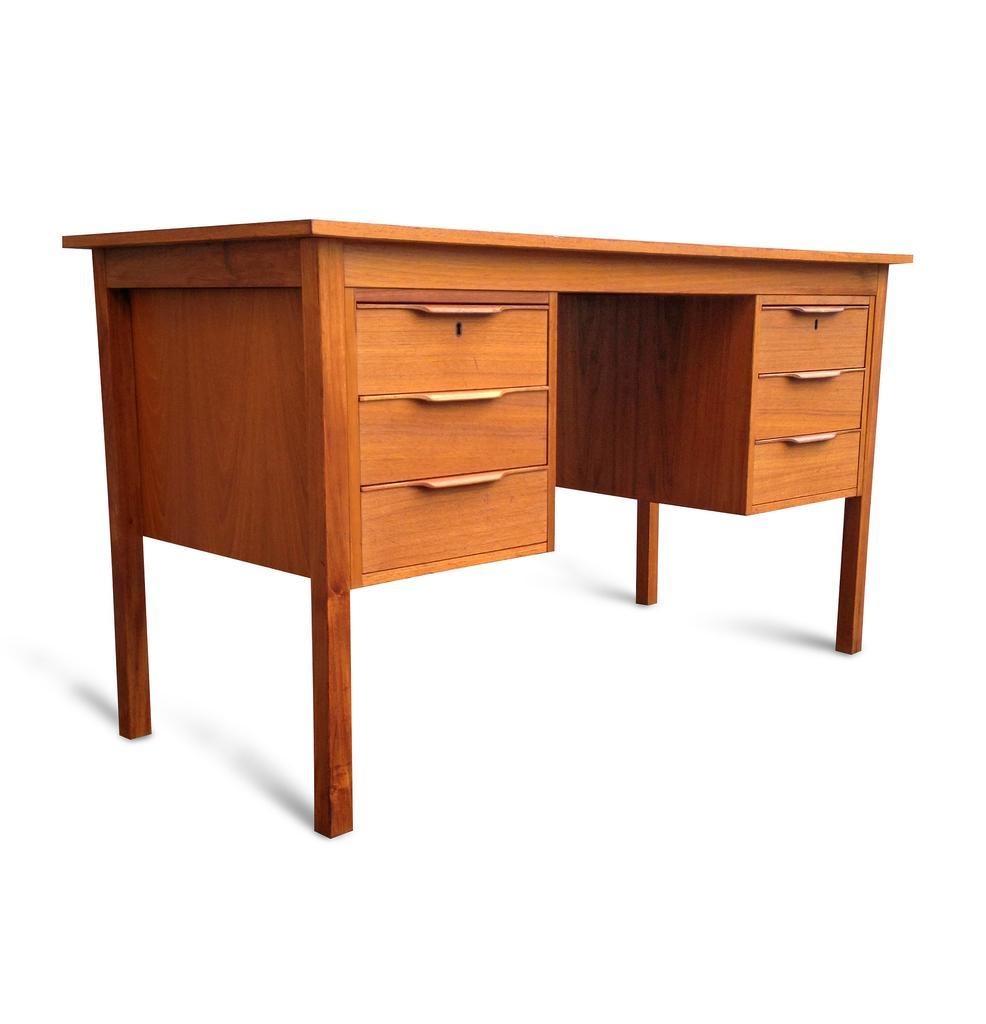Could you give a brief overview of what you see in this image? This picture shows a table 